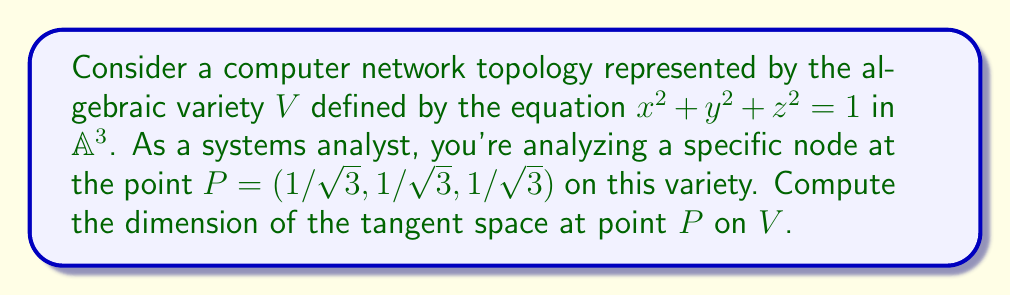Provide a solution to this math problem. To find the dimension of the tangent space at point $P$ on the algebraic variety $V$, we follow these steps:

1) The tangent space at a point on an algebraic variety is the vector space spanned by the partial derivatives of the defining equation(s) evaluated at that point.

2) Let $f(x,y,z) = x^2 + y^2 + z^2 - 1 = 0$ be the defining equation of $V$.

3) Calculate the partial derivatives:
   $$\frac{\partial f}{\partial x} = 2x$$
   $$\frac{\partial f}{\partial y} = 2y$$
   $$\frac{\partial f}{\partial z} = 2z$$

4) Evaluate these partial derivatives at $P = (1/\sqrt{3}, 1/\sqrt{3}, 1/\sqrt{3})$:
   $$\frac{\partial f}{\partial x}|_P = \frac{2}{\sqrt{3}}$$
   $$\frac{\partial f}{\partial y}|_P = \frac{2}{\sqrt{3}}$$
   $$\frac{\partial f}{\partial z}|_P = \frac{2}{\sqrt{3}}$$

5) The gradient vector at $P$ is:
   $$\nabla f|_P = (\frac{2}{\sqrt{3}}, \frac{2}{\sqrt{3}}, \frac{2}{\sqrt{3}})$$

6) This gradient vector is normal to the tangent space at $P$. The tangent space is the plane perpendicular to this vector.

7) The dimension of the tangent space is equal to the dimension of the ambient space (3 in this case) minus the rank of the Jacobian matrix (which is 1 in this case, as we have one non-zero gradient vector).

Therefore, the dimension of the tangent space at $P$ is $3 - 1 = 2$.
Answer: 2 